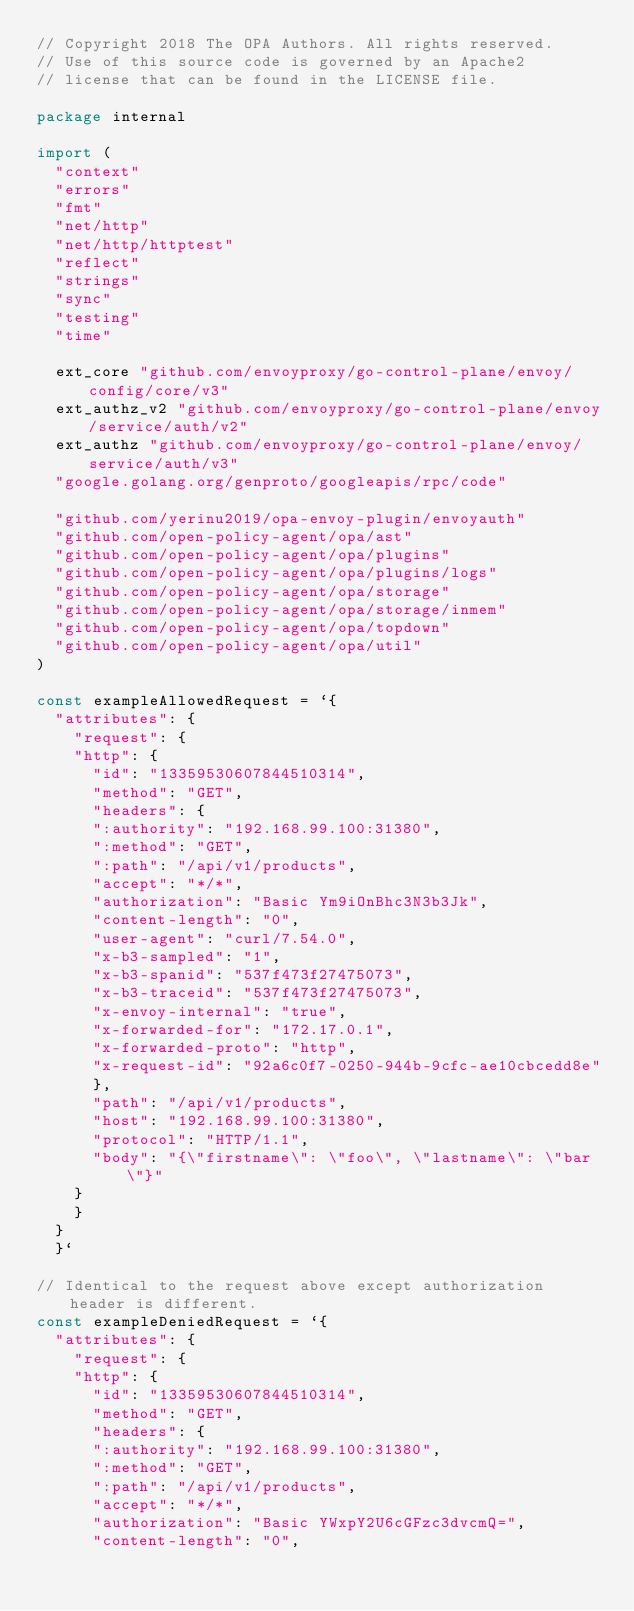Convert code to text. <code><loc_0><loc_0><loc_500><loc_500><_Go_>// Copyright 2018 The OPA Authors. All rights reserved.
// Use of this source code is governed by an Apache2
// license that can be found in the LICENSE file.

package internal

import (
	"context"
	"errors"
	"fmt"
	"net/http"
	"net/http/httptest"
	"reflect"
	"strings"
	"sync"
	"testing"
	"time"

	ext_core "github.com/envoyproxy/go-control-plane/envoy/config/core/v3"
	ext_authz_v2 "github.com/envoyproxy/go-control-plane/envoy/service/auth/v2"
	ext_authz "github.com/envoyproxy/go-control-plane/envoy/service/auth/v3"
	"google.golang.org/genproto/googleapis/rpc/code"

	"github.com/yerinu2019/opa-envoy-plugin/envoyauth"
	"github.com/open-policy-agent/opa/ast"
	"github.com/open-policy-agent/opa/plugins"
	"github.com/open-policy-agent/opa/plugins/logs"
	"github.com/open-policy-agent/opa/storage"
	"github.com/open-policy-agent/opa/storage/inmem"
	"github.com/open-policy-agent/opa/topdown"
	"github.com/open-policy-agent/opa/util"
)

const exampleAllowedRequest = `{
	"attributes": {
	  "request": {
		"http": {
		  "id": "13359530607844510314",
		  "method": "GET",
		  "headers": {
			":authority": "192.168.99.100:31380",
			":method": "GET",
			":path": "/api/v1/products",
			"accept": "*/*",
			"authorization": "Basic Ym9iOnBhc3N3b3Jk",
			"content-length": "0",
			"user-agent": "curl/7.54.0",
			"x-b3-sampled": "1",
			"x-b3-spanid": "537f473f27475073",
			"x-b3-traceid": "537f473f27475073",
			"x-envoy-internal": "true",
			"x-forwarded-for": "172.17.0.1",
			"x-forwarded-proto": "http",
			"x-request-id": "92a6c0f7-0250-944b-9cfc-ae10cbcedd8e"
		  },
		  "path": "/api/v1/products",
		  "host": "192.168.99.100:31380",
		  "protocol": "HTTP/1.1",
		  "body": "{\"firstname\": \"foo\", \"lastname\": \"bar\"}"
		}
	  }
	}
  }`

// Identical to the request above except authorization header is different.
const exampleDeniedRequest = `{
	"attributes": {
	  "request": {
		"http": {
		  "id": "13359530607844510314",
		  "method": "GET",
		  "headers": {
			":authority": "192.168.99.100:31380",
			":method": "GET",
			":path": "/api/v1/products",
			"accept": "*/*",
			"authorization": "Basic YWxpY2U6cGFzc3dvcmQ=",
			"content-length": "0",</code> 